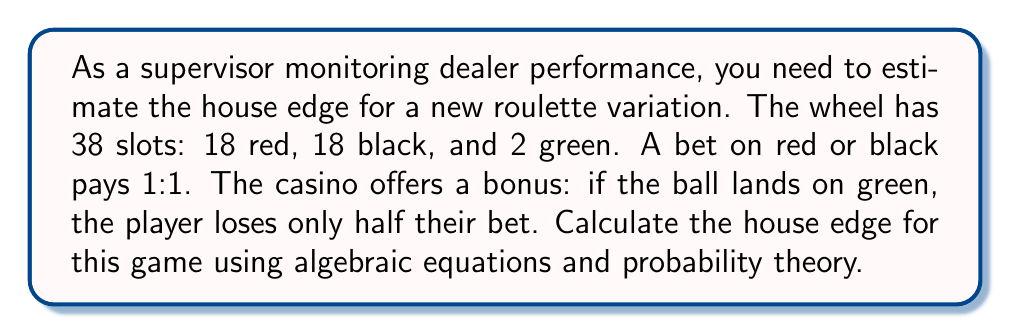Could you help me with this problem? Let's approach this step-by-step:

1) First, let's define our variables:
   $x$ = amount bet
   $p_w$ = probability of winning
   $p_l$ = probability of losing
   $p_g$ = probability of green (bonus)

2) Calculate probabilities:
   $p_w = \frac{18}{38}$
   $p_l = \frac{18}{38}$
   $p_g = \frac{2}{38}$

3) Expected value of the bet:
   $E(x) = p_w(x) + p_l(-x) + p_g(-\frac{1}{2}x)$

4) Substitute the probabilities:
   $E(x) = \frac{18}{38}x - \frac{18}{38}x - \frac{2}{38}(\frac{1}{2}x)$

5) Simplify:
   $E(x) = \frac{18x - 18x - x}{38} = -\frac{x}{38}$

6) The house edge is the negative of the expected value divided by the bet:
   $\text{House Edge} = -\frac{E(x)}{x} = -(-\frac{1}{38}) = \frac{1}{38}$

7) Convert to percentage:
   $\text{House Edge} = \frac{1}{38} \approx 0.0263 = 2.63\%$
Answer: $\frac{1}{38}$ or 2.63% 